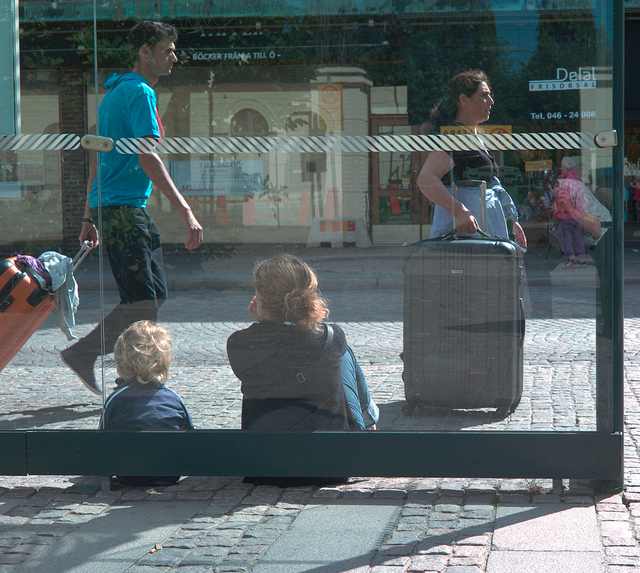<image>Does the woman on the right have a small carry-on bag? I don't know if the woman on the right has a small carry-on bag. Does the woman on the right have a small carry-on bag? I don't know if the woman on the right has a small carry-on bag. 